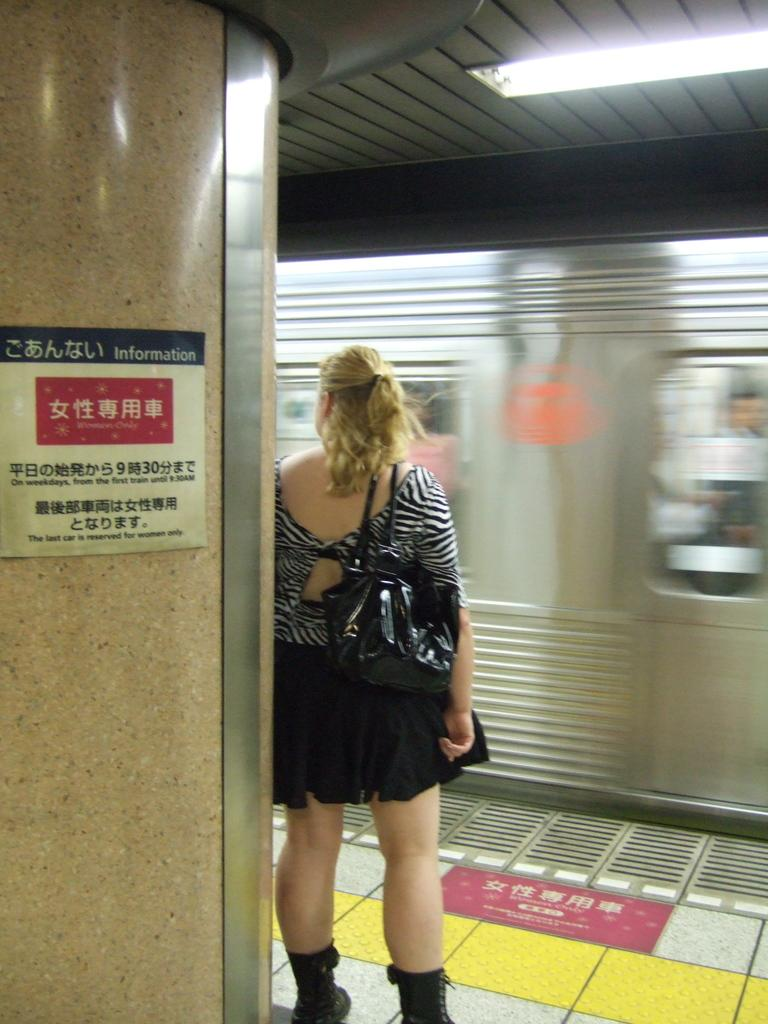What is the woman doing near the train in the image? The woman is standing near the train in the image. What can be seen on the left side of the image? There is a pillar on the left side of the image. What is the purpose of the light in the top roof of the train? The light in the top roof of the train is likely for illumination or visibility. Is the woman wearing a veil in the image? There is no mention of a veil in the image, so we cannot determine if the woman is wearing one. Can you see the woman's veins in the image? The image does not provide enough detail to see the woman's veins. 